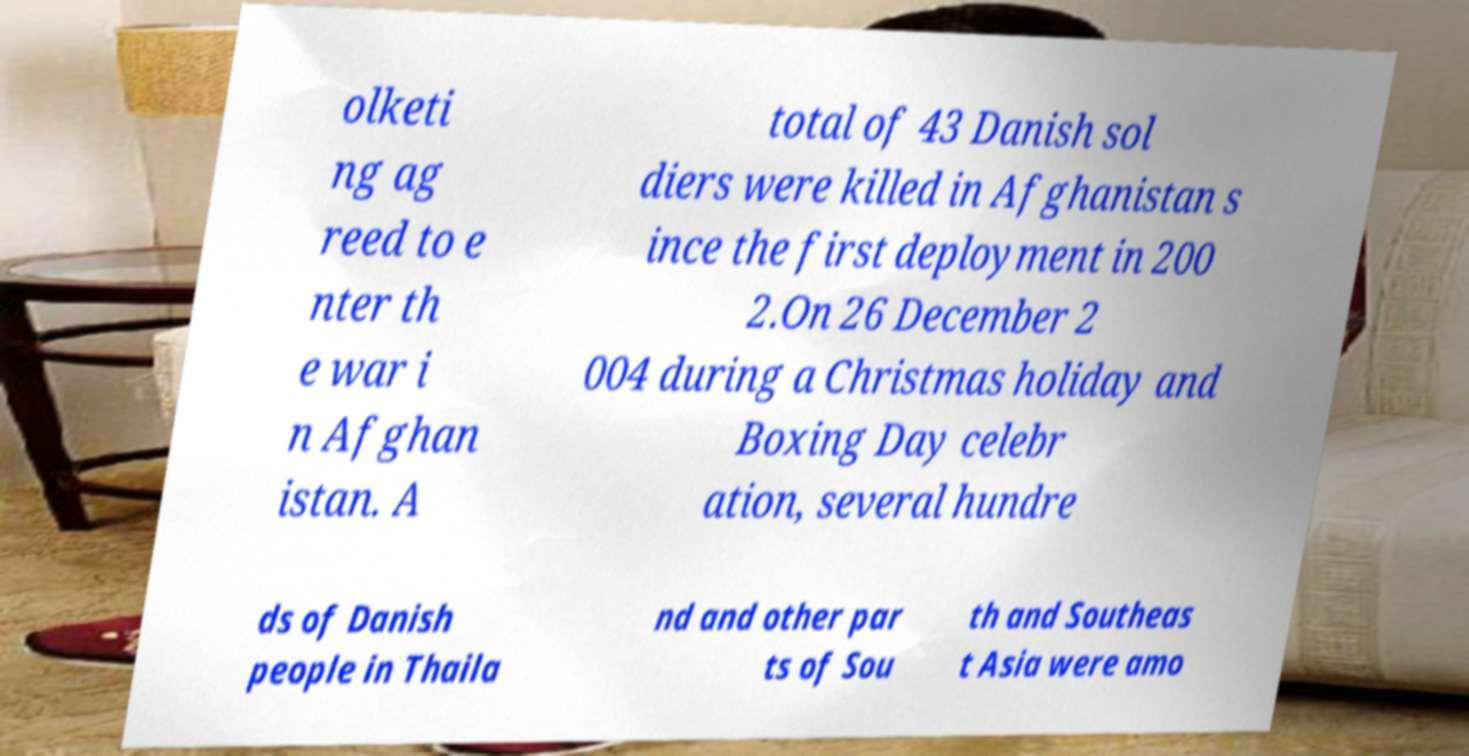Could you assist in decoding the text presented in this image and type it out clearly? olketi ng ag reed to e nter th e war i n Afghan istan. A total of 43 Danish sol diers were killed in Afghanistan s ince the first deployment in 200 2.On 26 December 2 004 during a Christmas holiday and Boxing Day celebr ation, several hundre ds of Danish people in Thaila nd and other par ts of Sou th and Southeas t Asia were amo 